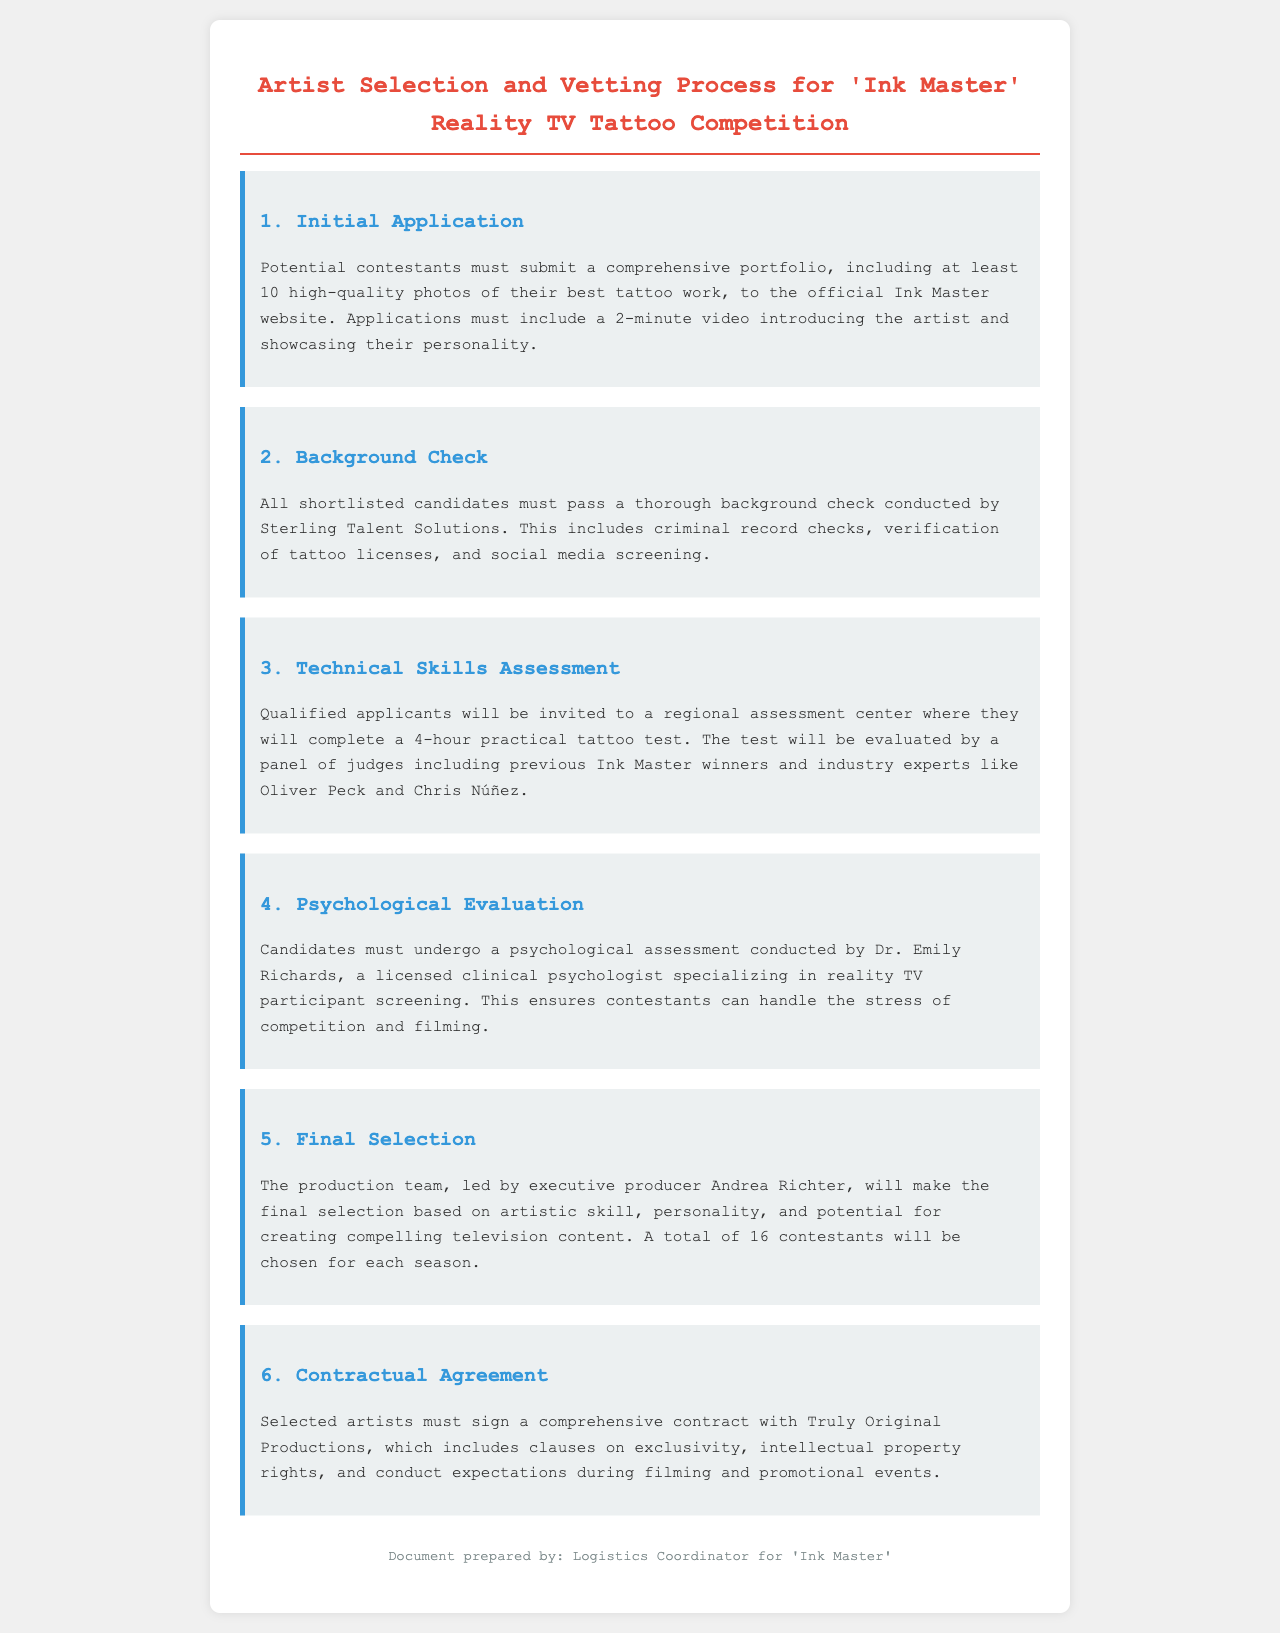What must potential contestants submit? Potential contestants must submit a comprehensive portfolio, including at least 10 high-quality photos of their best tattoo work and a 2-minute video introducing the artist.
Answer: Portfolio and video Who conducts the background check? The background check is conducted by Sterling Talent Solutions.
Answer: Sterling Talent Solutions How long is the practical tattoo test? The practical tattoo test lasts for 4 hours.
Answer: 4 hours Who evaluates the technical skills assessment? The assessment will be evaluated by a panel of judges, including previous Ink Master winners and industry experts.
Answer: Judges and experts How many contestants are chosen for each season? A total of 16 contestants will be chosen for each season.
Answer: 16 contestants What type of evaluation must candidates undergo? Candidates must undergo a psychological assessment.
Answer: Psychological assessment Who is the executive producer responsible for final selection? The final selection is led by executive producer Andrea Richter.
Answer: Andrea Richter What must selected artists sign? Selected artists must sign a comprehensive contract.
Answer: Comprehensive contract 